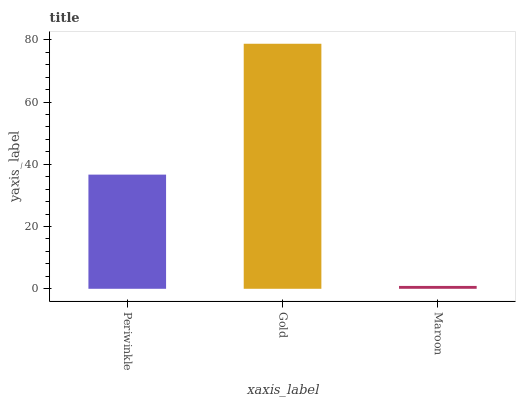Is Maroon the minimum?
Answer yes or no. Yes. Is Gold the maximum?
Answer yes or no. Yes. Is Gold the minimum?
Answer yes or no. No. Is Maroon the maximum?
Answer yes or no. No. Is Gold greater than Maroon?
Answer yes or no. Yes. Is Maroon less than Gold?
Answer yes or no. Yes. Is Maroon greater than Gold?
Answer yes or no. No. Is Gold less than Maroon?
Answer yes or no. No. Is Periwinkle the high median?
Answer yes or no. Yes. Is Periwinkle the low median?
Answer yes or no. Yes. Is Maroon the high median?
Answer yes or no. No. Is Maroon the low median?
Answer yes or no. No. 